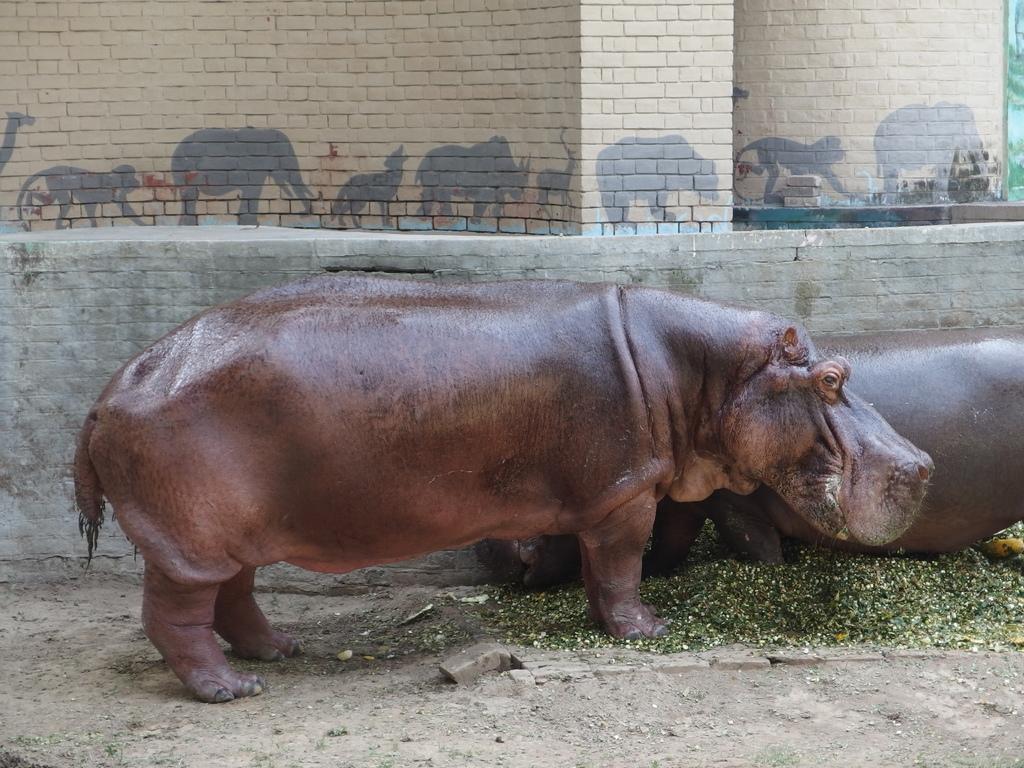Please provide a concise description of this image. This image consists of hippopotamus. There are two hippopotamuses. They are in brown color. 